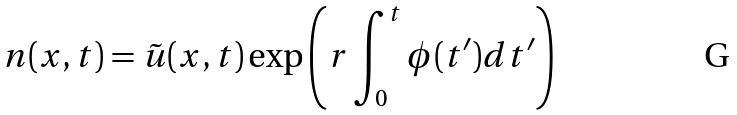<formula> <loc_0><loc_0><loc_500><loc_500>n ( x , t ) = \tilde { u } ( x , t ) \exp \left ( r \int _ { 0 } ^ { t } \phi ( t ^ { \prime } ) d t ^ { \prime } \right )</formula> 